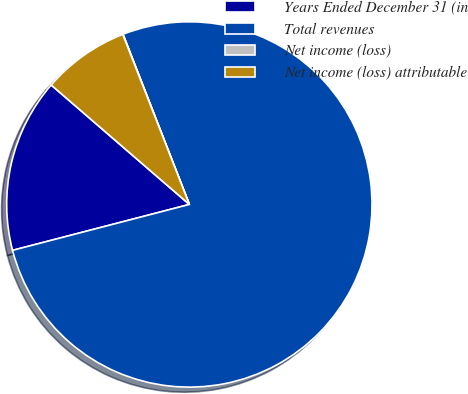<chart> <loc_0><loc_0><loc_500><loc_500><pie_chart><fcel>Years Ended December 31 (in<fcel>Total revenues<fcel>Net income (loss)<fcel>Net income (loss) attributable<nl><fcel>15.39%<fcel>76.87%<fcel>0.03%<fcel>7.71%<nl></chart> 